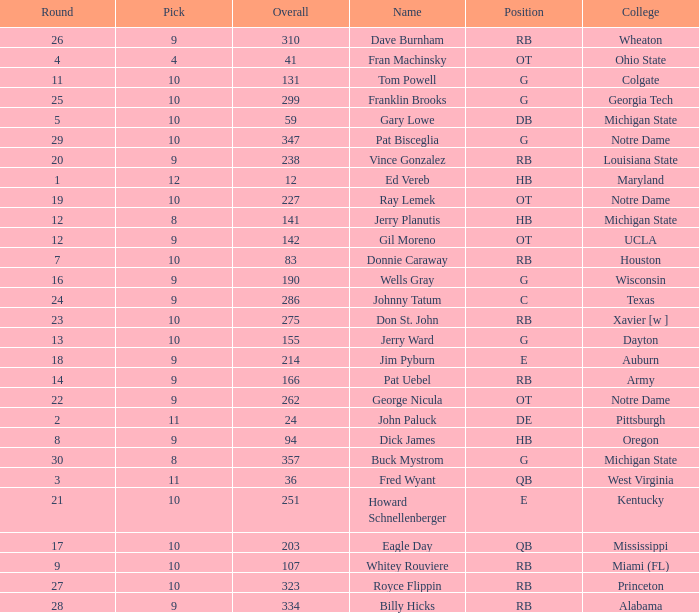Could you parse the entire table? {'header': ['Round', 'Pick', 'Overall', 'Name', 'Position', 'College'], 'rows': [['26', '9', '310', 'Dave Burnham', 'RB', 'Wheaton'], ['4', '4', '41', 'Fran Machinsky', 'OT', 'Ohio State'], ['11', '10', '131', 'Tom Powell', 'G', 'Colgate'], ['25', '10', '299', 'Franklin Brooks', 'G', 'Georgia Tech'], ['5', '10', '59', 'Gary Lowe', 'DB', 'Michigan State'], ['29', '10', '347', 'Pat Bisceglia', 'G', 'Notre Dame'], ['20', '9', '238', 'Vince Gonzalez', 'RB', 'Louisiana State'], ['1', '12', '12', 'Ed Vereb', 'HB', 'Maryland'], ['19', '10', '227', 'Ray Lemek', 'OT', 'Notre Dame'], ['12', '8', '141', 'Jerry Planutis', 'HB', 'Michigan State'], ['12', '9', '142', 'Gil Moreno', 'OT', 'UCLA'], ['7', '10', '83', 'Donnie Caraway', 'RB', 'Houston'], ['16', '9', '190', 'Wells Gray', 'G', 'Wisconsin'], ['24', '9', '286', 'Johnny Tatum', 'C', 'Texas'], ['23', '10', '275', 'Don St. John', 'RB', 'Xavier [w ]'], ['13', '10', '155', 'Jerry Ward', 'G', 'Dayton'], ['18', '9', '214', 'Jim Pyburn', 'E', 'Auburn'], ['14', '9', '166', 'Pat Uebel', 'RB', 'Army'], ['22', '9', '262', 'George Nicula', 'OT', 'Notre Dame'], ['2', '11', '24', 'John Paluck', 'DE', 'Pittsburgh'], ['8', '9', '94', 'Dick James', 'HB', 'Oregon'], ['30', '8', '357', 'Buck Mystrom', 'G', 'Michigan State'], ['3', '11', '36', 'Fred Wyant', 'QB', 'West Virginia'], ['21', '10', '251', 'Howard Schnellenberger', 'E', 'Kentucky'], ['17', '10', '203', 'Eagle Day', 'QB', 'Mississippi'], ['9', '10', '107', 'Whitey Rouviere', 'RB', 'Miami (FL)'], ['27', '10', '323', 'Royce Flippin', 'RB', 'Princeton'], ['28', '9', '334', 'Billy Hicks', 'RB', 'Alabama']]} What is the highest overall pick number for george nicula who had a pick smaller than 9? None. 